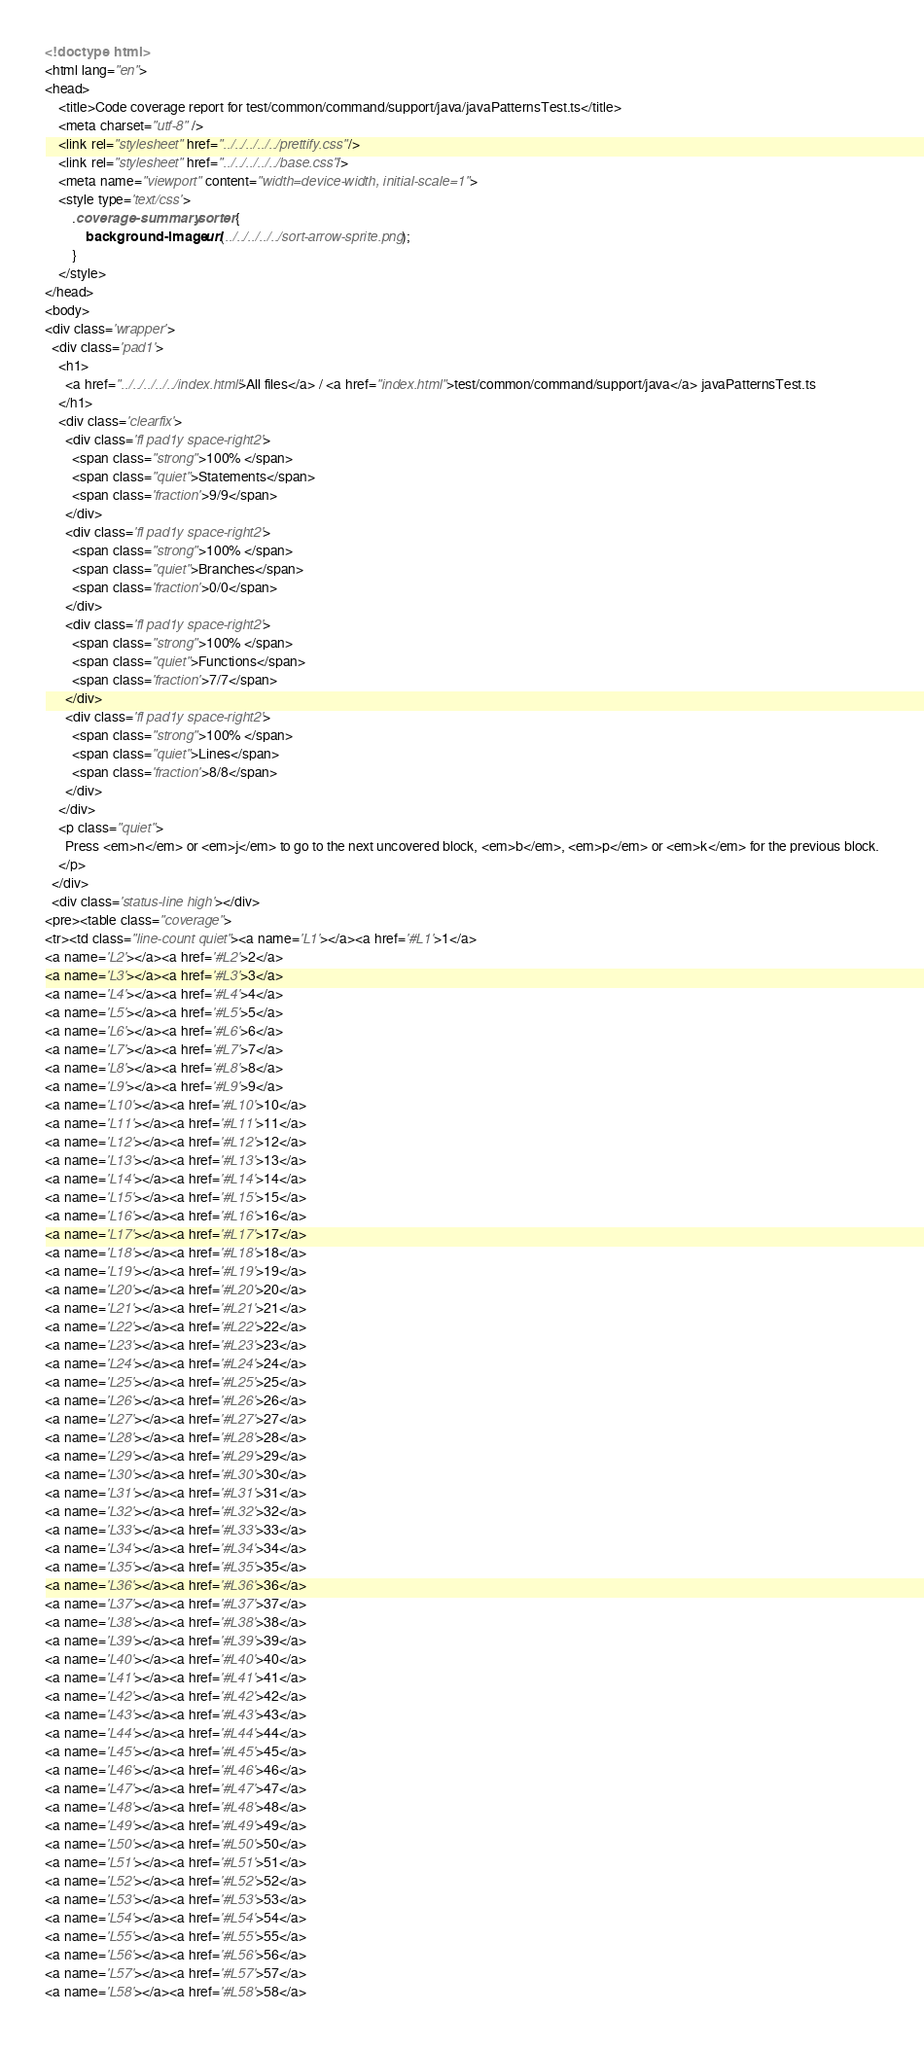Convert code to text. <code><loc_0><loc_0><loc_500><loc_500><_HTML_><!doctype html>
<html lang="en">
<head>
    <title>Code coverage report for test/common/command/support/java/javaPatternsTest.ts</title>
    <meta charset="utf-8" />
    <link rel="stylesheet" href="../../../../../prettify.css" />
    <link rel="stylesheet" href="../../../../../base.css" />
    <meta name="viewport" content="width=device-width, initial-scale=1">
    <style type='text/css'>
        .coverage-summary .sorter {
            background-image: url(../../../../../sort-arrow-sprite.png);
        }
    </style>
</head>
<body>
<div class='wrapper'>
  <div class='pad1'>
    <h1>
      <a href="../../../../../index.html">All files</a> / <a href="index.html">test/common/command/support/java</a> javaPatternsTest.ts
    </h1>
    <div class='clearfix'>
      <div class='fl pad1y space-right2'>
        <span class="strong">100% </span>
        <span class="quiet">Statements</span>
        <span class='fraction'>9/9</span>
      </div>
      <div class='fl pad1y space-right2'>
        <span class="strong">100% </span>
        <span class="quiet">Branches</span>
        <span class='fraction'>0/0</span>
      </div>
      <div class='fl pad1y space-right2'>
        <span class="strong">100% </span>
        <span class="quiet">Functions</span>
        <span class='fraction'>7/7</span>
      </div>
      <div class='fl pad1y space-right2'>
        <span class="strong">100% </span>
        <span class="quiet">Lines</span>
        <span class='fraction'>8/8</span>
      </div>
    </div>
    <p class="quiet">
      Press <em>n</em> or <em>j</em> to go to the next uncovered block, <em>b</em>, <em>p</em> or <em>k</em> for the previous block.
    </p>
  </div>
  <div class='status-line high'></div>
<pre><table class="coverage">
<tr><td class="line-count quiet"><a name='L1'></a><a href='#L1'>1</a>
<a name='L2'></a><a href='#L2'>2</a>
<a name='L3'></a><a href='#L3'>3</a>
<a name='L4'></a><a href='#L4'>4</a>
<a name='L5'></a><a href='#L5'>5</a>
<a name='L6'></a><a href='#L6'>6</a>
<a name='L7'></a><a href='#L7'>7</a>
<a name='L8'></a><a href='#L8'>8</a>
<a name='L9'></a><a href='#L9'>9</a>
<a name='L10'></a><a href='#L10'>10</a>
<a name='L11'></a><a href='#L11'>11</a>
<a name='L12'></a><a href='#L12'>12</a>
<a name='L13'></a><a href='#L13'>13</a>
<a name='L14'></a><a href='#L14'>14</a>
<a name='L15'></a><a href='#L15'>15</a>
<a name='L16'></a><a href='#L16'>16</a>
<a name='L17'></a><a href='#L17'>17</a>
<a name='L18'></a><a href='#L18'>18</a>
<a name='L19'></a><a href='#L19'>19</a>
<a name='L20'></a><a href='#L20'>20</a>
<a name='L21'></a><a href='#L21'>21</a>
<a name='L22'></a><a href='#L22'>22</a>
<a name='L23'></a><a href='#L23'>23</a>
<a name='L24'></a><a href='#L24'>24</a>
<a name='L25'></a><a href='#L25'>25</a>
<a name='L26'></a><a href='#L26'>26</a>
<a name='L27'></a><a href='#L27'>27</a>
<a name='L28'></a><a href='#L28'>28</a>
<a name='L29'></a><a href='#L29'>29</a>
<a name='L30'></a><a href='#L30'>30</a>
<a name='L31'></a><a href='#L31'>31</a>
<a name='L32'></a><a href='#L32'>32</a>
<a name='L33'></a><a href='#L33'>33</a>
<a name='L34'></a><a href='#L34'>34</a>
<a name='L35'></a><a href='#L35'>35</a>
<a name='L36'></a><a href='#L36'>36</a>
<a name='L37'></a><a href='#L37'>37</a>
<a name='L38'></a><a href='#L38'>38</a>
<a name='L39'></a><a href='#L39'>39</a>
<a name='L40'></a><a href='#L40'>40</a>
<a name='L41'></a><a href='#L41'>41</a>
<a name='L42'></a><a href='#L42'>42</a>
<a name='L43'></a><a href='#L43'>43</a>
<a name='L44'></a><a href='#L44'>44</a>
<a name='L45'></a><a href='#L45'>45</a>
<a name='L46'></a><a href='#L46'>46</a>
<a name='L47'></a><a href='#L47'>47</a>
<a name='L48'></a><a href='#L48'>48</a>
<a name='L49'></a><a href='#L49'>49</a>
<a name='L50'></a><a href='#L50'>50</a>
<a name='L51'></a><a href='#L51'>51</a>
<a name='L52'></a><a href='#L52'>52</a>
<a name='L53'></a><a href='#L53'>53</a>
<a name='L54'></a><a href='#L54'>54</a>
<a name='L55'></a><a href='#L55'>55</a>
<a name='L56'></a><a href='#L56'>56</a>
<a name='L57'></a><a href='#L57'>57</a>
<a name='L58'></a><a href='#L58'>58</a></code> 